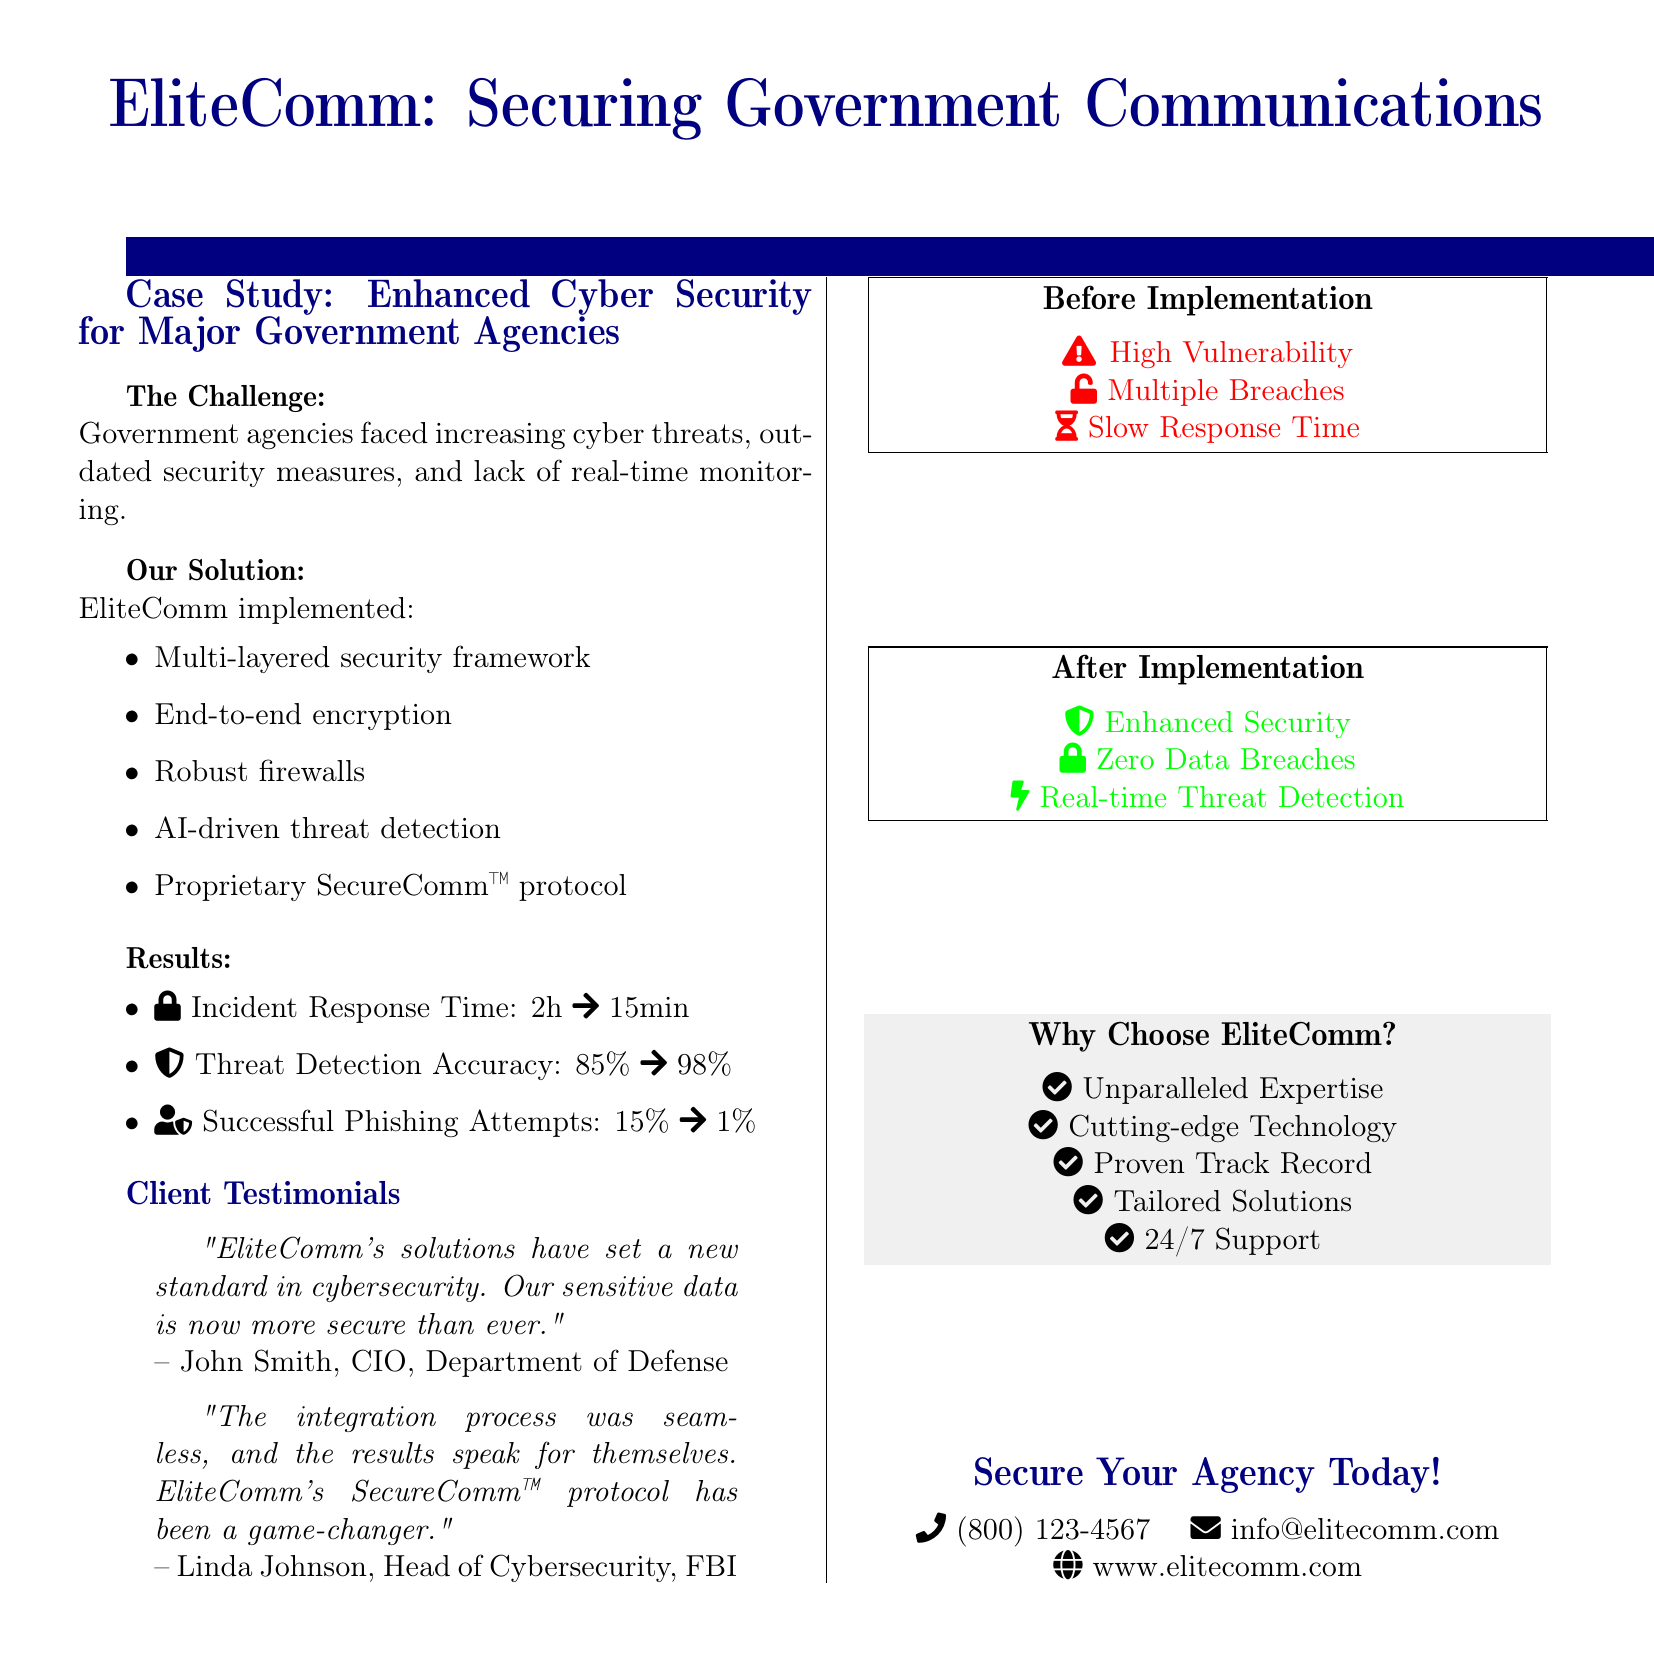What was the incident response time before implementation? The incident response time improved from 2 hours to 15 minutes, indicating the initial time was 2 hours.
Answer: 2 hours What is the successful phishing attempt rate after implementation? The document states that the successful phishing attempts decreased from 15% to 1%, so the after rate is 1%.
Answer: 1% Who is the Head of Cybersecurity for the FBI? According to the client testimonial, the Head of Cybersecurity for the FBI is Linda Johnson.
Answer: Linda Johnson What does the SecureComm™ protocol represent? The SecureComm™ protocol is highlighted as part of the solution, suggesting it is a specific security measure implemented in the government agencies.
Answer: Proprietary SecureComm™ protocol What kind of technology does EliteComm use for threat detection? The document mentions that AI-driven technology is utilized for threat detection, indicating a specific approach they take.
Answer: AI-driven threat detection What are the stated indicators of enhanced security after implementation? The document lists "Enhanced Security," "Zero Data Breaches," and "Real-time Threat Detection" as the key indicators after implementation.
Answer: Enhanced Security; Zero Data Breaches; Real-time Threat Detection What color represents high vulnerability in the before visuals? The before visuals show high vulnerability highlighted in red, which corresponds to a specific indicator of security status.
Answer: Red What is a key reason to choose EliteComm? The document provides several reasons, one of them being "Unparalleled Expertise," indicating a focus on their qualifications.
Answer: Unparalleled Expertise 